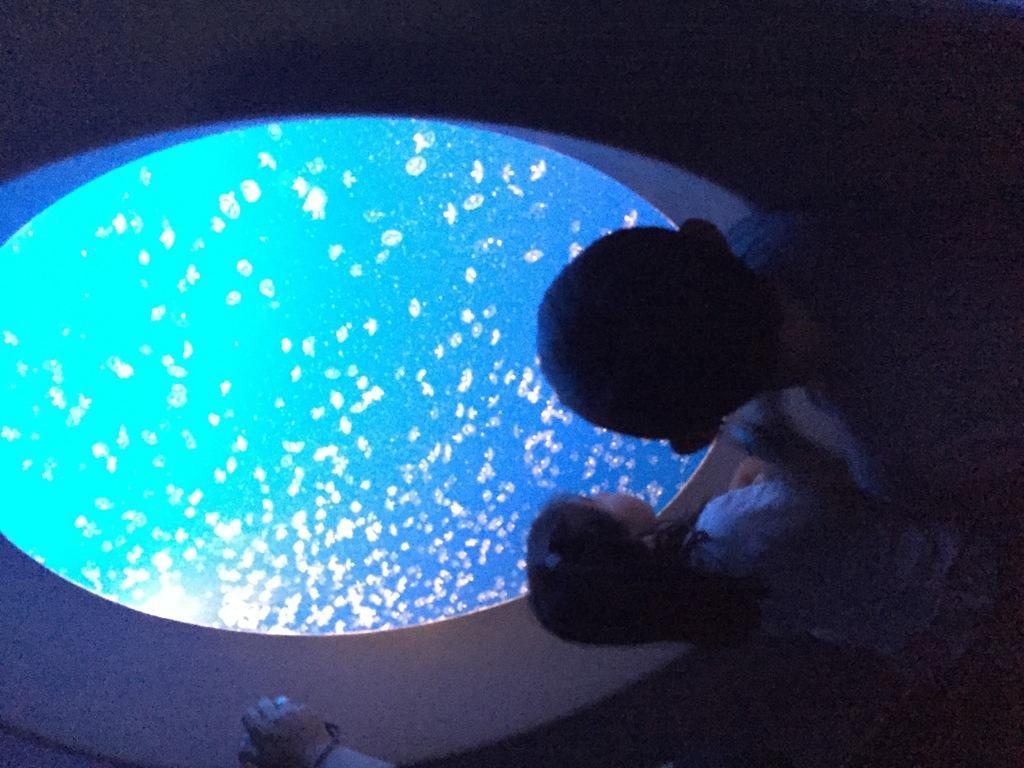Could you give a brief overview of what you see in this image? In this picture we can see few people and dark background. 